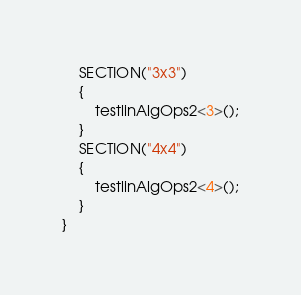Convert code to text. <code><loc_0><loc_0><loc_500><loc_500><_Cuda_>	SECTION("3x3")
	{
		testlinAlgOps2<3>();
	}
	SECTION("4x4")
	{
		testlinAlgOps2<4>();
	}
}</code> 